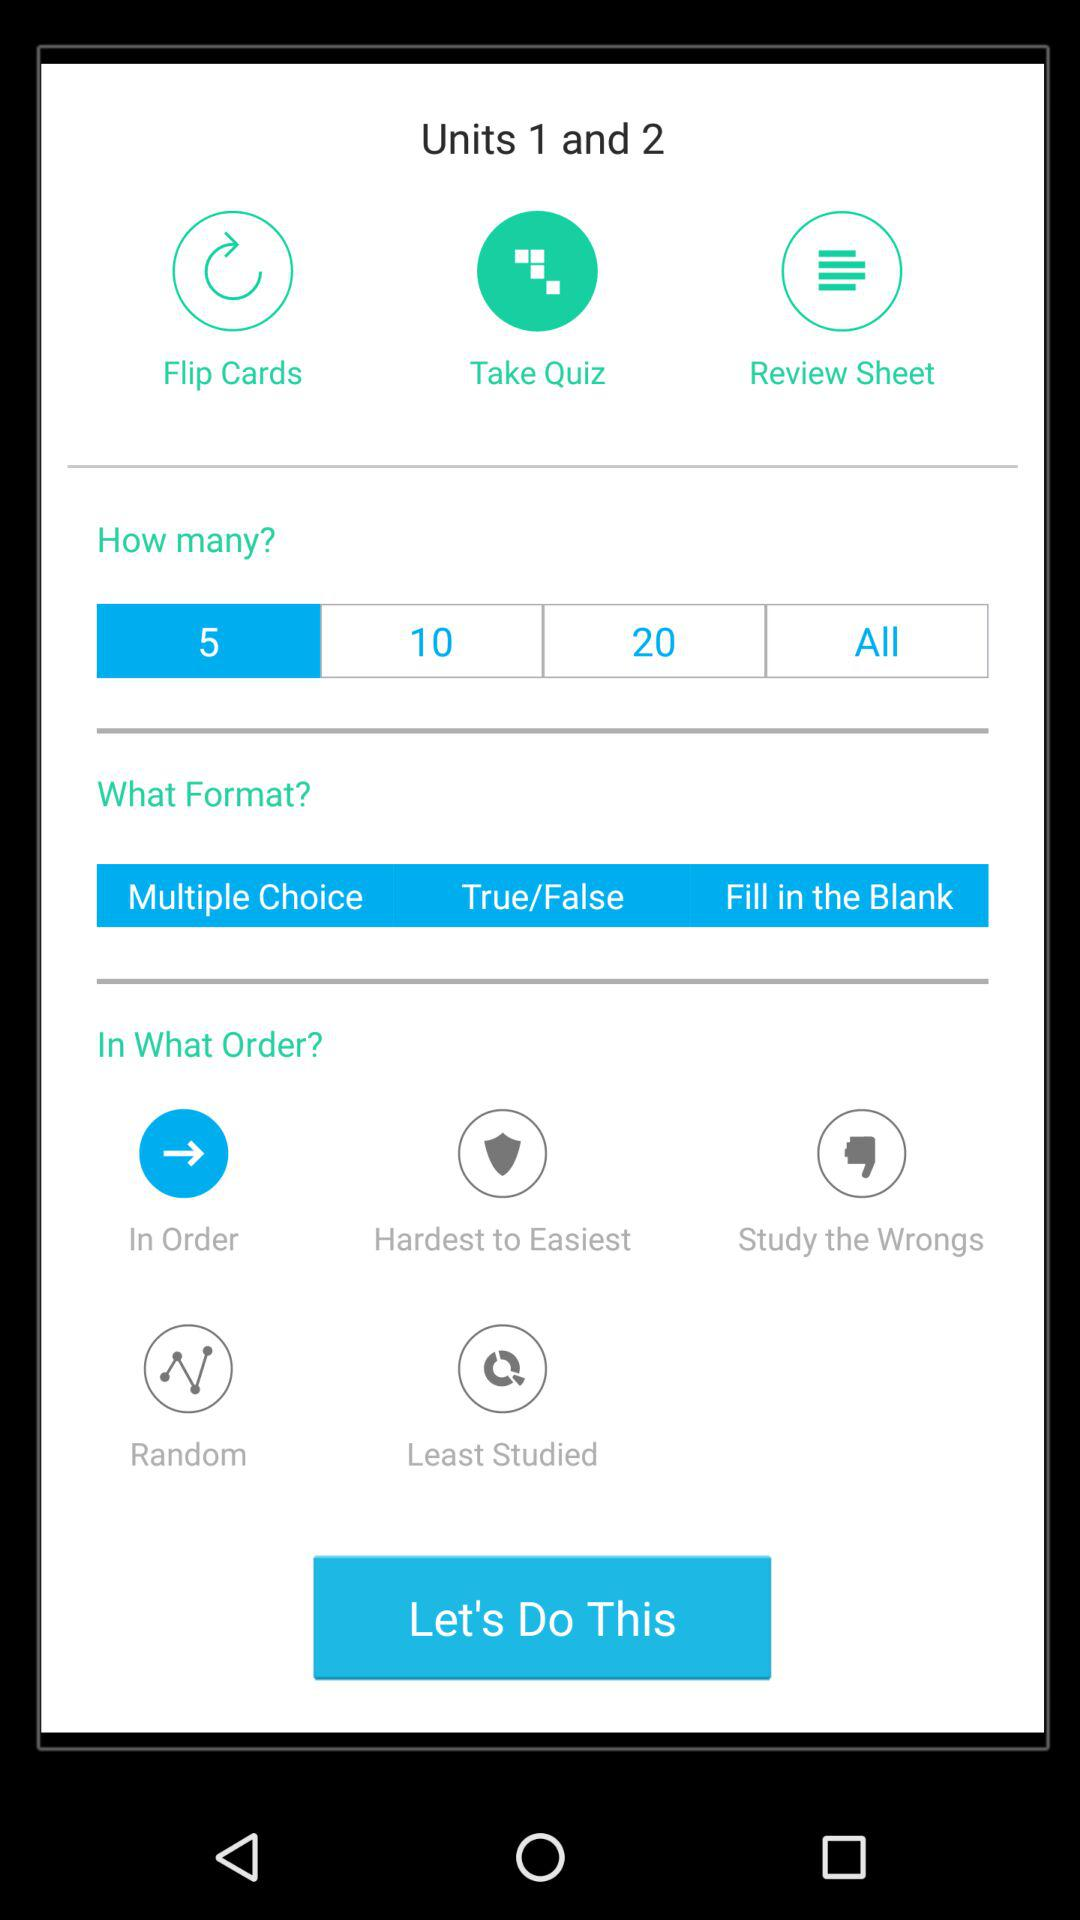Which number is selected in "How many?"? The selected number is "5". 